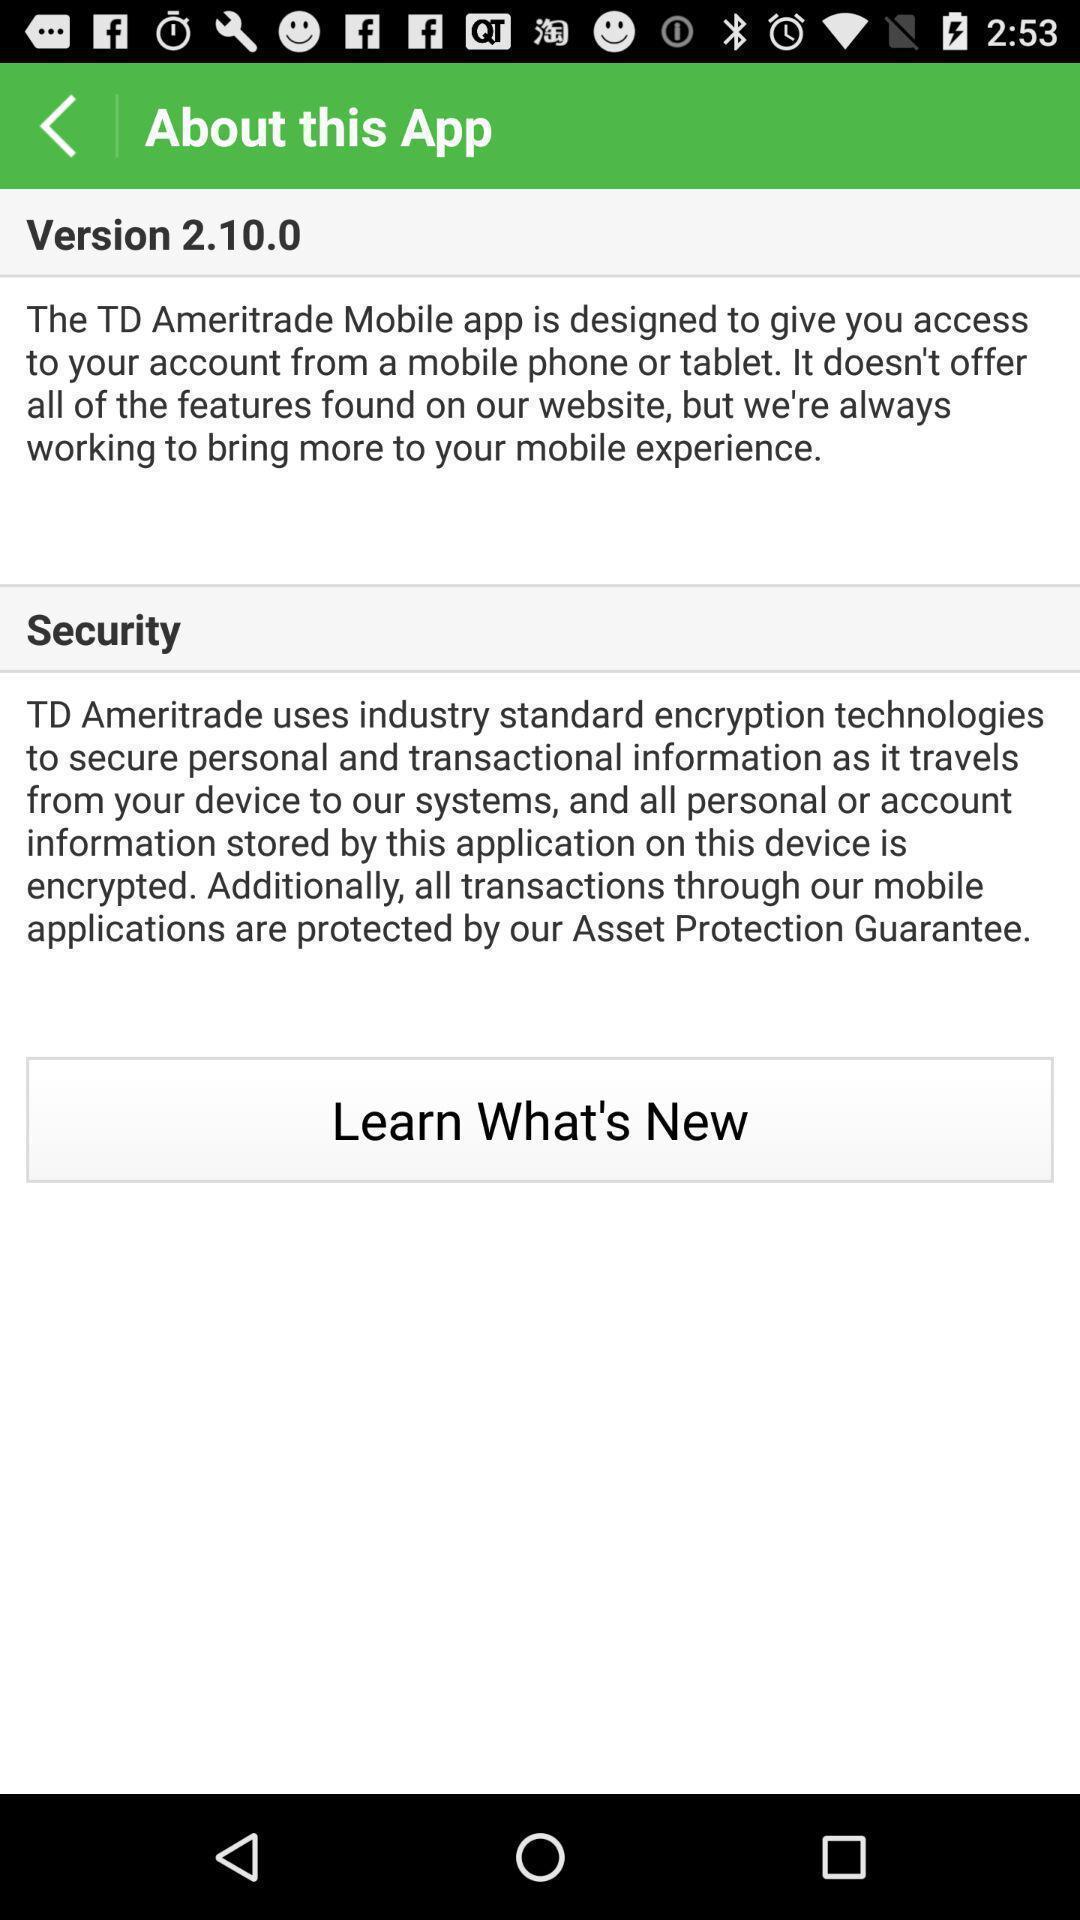Provide a detailed account of this screenshot. Screen shows about details. 